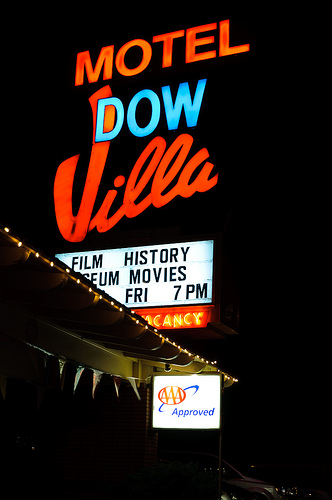<image>
Is the dow under the motel? Yes. The dow is positioned underneath the motel, with the motel above it in the vertical space. 